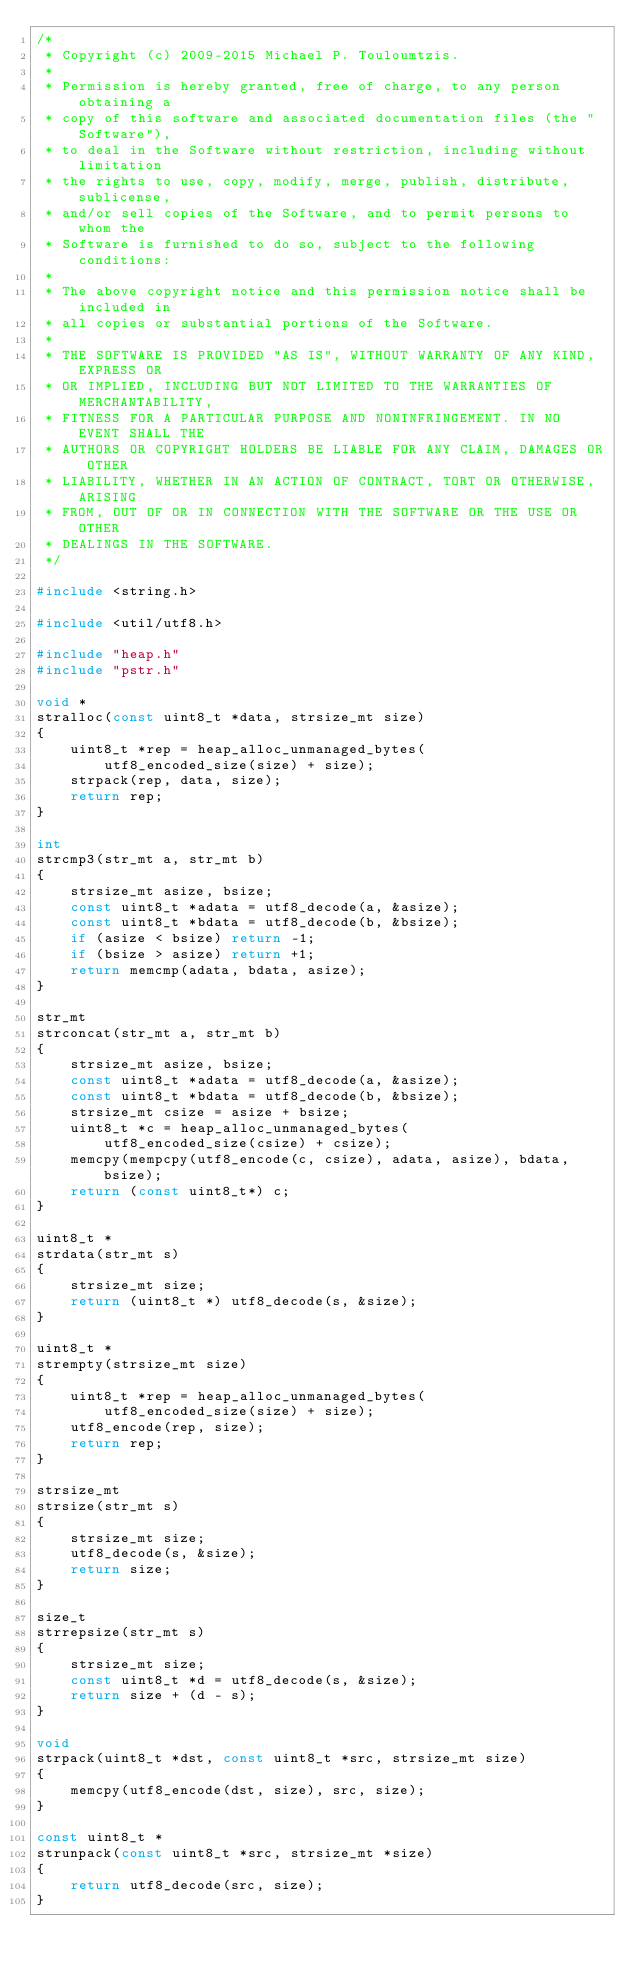Convert code to text. <code><loc_0><loc_0><loc_500><loc_500><_C_>/*
 * Copyright (c) 2009-2015 Michael P. Touloumtzis.
 *
 * Permission is hereby granted, free of charge, to any person obtaining a
 * copy of this software and associated documentation files (the "Software"),
 * to deal in the Software without restriction, including without limitation
 * the rights to use, copy, modify, merge, publish, distribute, sublicense,
 * and/or sell copies of the Software, and to permit persons to whom the
 * Software is furnished to do so, subject to the following conditions:
 *
 * The above copyright notice and this permission notice shall be included in
 * all copies or substantial portions of the Software.
 *
 * THE SOFTWARE IS PROVIDED "AS IS", WITHOUT WARRANTY OF ANY KIND, EXPRESS OR
 * OR IMPLIED, INCLUDING BUT NOT LIMITED TO THE WARRANTIES OF MERCHANTABILITY,
 * FITNESS FOR A PARTICULAR PURPOSE AND NONINFRINGEMENT. IN NO EVENT SHALL THE
 * AUTHORS OR COPYRIGHT HOLDERS BE LIABLE FOR ANY CLAIM, DAMAGES OR OTHER
 * LIABILITY, WHETHER IN AN ACTION OF CONTRACT, TORT OR OTHERWISE, ARISING
 * FROM, OUT OF OR IN CONNECTION WITH THE SOFTWARE OR THE USE OR OTHER
 * DEALINGS IN THE SOFTWARE.
 */

#include <string.h>

#include <util/utf8.h>

#include "heap.h"
#include "pstr.h"

void *
stralloc(const uint8_t *data, strsize_mt size)
{
	uint8_t *rep = heap_alloc_unmanaged_bytes(
		utf8_encoded_size(size) + size);
	strpack(rep, data, size);
	return rep;
}

int
strcmp3(str_mt a, str_mt b)
{
	strsize_mt asize, bsize;
	const uint8_t *adata = utf8_decode(a, &asize);
	const uint8_t *bdata = utf8_decode(b, &bsize);
	if (asize < bsize) return -1;
	if (bsize > asize) return +1;
	return memcmp(adata, bdata, asize);
}

str_mt
strconcat(str_mt a, str_mt b)
{
	strsize_mt asize, bsize;
	const uint8_t *adata = utf8_decode(a, &asize);
	const uint8_t *bdata = utf8_decode(b, &bsize);
	strsize_mt csize = asize + bsize;
	uint8_t *c = heap_alloc_unmanaged_bytes(
		utf8_encoded_size(csize) + csize);
	memcpy(mempcpy(utf8_encode(c, csize), adata, asize), bdata, bsize);
	return (const uint8_t*) c;
}

uint8_t *
strdata(str_mt s)
{
	strsize_mt size;
	return (uint8_t *) utf8_decode(s, &size);
}

uint8_t *
strempty(strsize_mt size)
{
	uint8_t *rep = heap_alloc_unmanaged_bytes(
		utf8_encoded_size(size) + size);
	utf8_encode(rep, size);
	return rep;
}

strsize_mt
strsize(str_mt s)
{
	strsize_mt size;
	utf8_decode(s, &size);
	return size;
}

size_t
strrepsize(str_mt s)
{
	strsize_mt size;
	const uint8_t *d = utf8_decode(s, &size);
	return size + (d - s);
}

void
strpack(uint8_t *dst, const uint8_t *src, strsize_mt size)
{
	memcpy(utf8_encode(dst, size), src, size);
}

const uint8_t *
strunpack(const uint8_t *src, strsize_mt *size)
{
	return utf8_decode(src, size);
}
</code> 